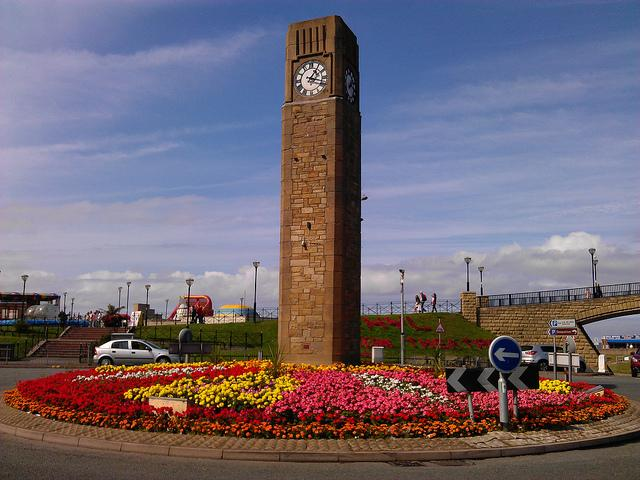What is the traffic pattern?

Choices:
A) intersection
B) dead end
C) highway
D) traffic circle intersection 